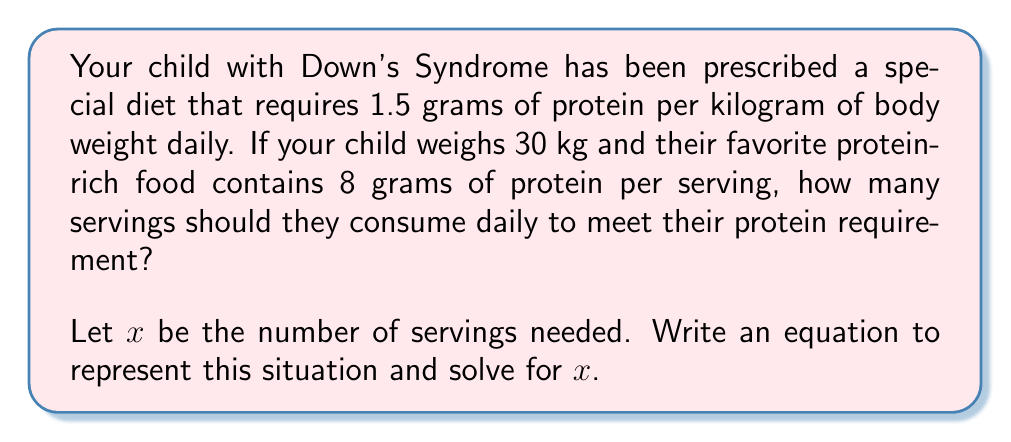Show me your answer to this math problem. Let's approach this step-by-step:

1) First, calculate the total protein requirement:
   $$ \text{Total protein} = 1.5 \text{ g/kg} \times 30 \text{ kg} = 45 \text{ g} $$

2) Now, let $x$ be the number of servings needed. Each serving contains 8 grams of protein.

3) We can write the equation:
   $$ 8x = 45 $$

   This equation states that the protein from $x$ servings should equal the daily requirement of 45 grams.

4) To solve for $x$, divide both sides by 8:
   $$ x = \frac{45}{8} = 5.625 $$

5) Since we can't have partial servings, we need to round up to ensure the protein requirement is met.
Answer: The child should consume 6 servings of the protein-rich food daily to meet their protein requirement. 